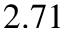Convert formula to latex. <formula><loc_0><loc_0><loc_500><loc_500>2 . 7 1</formula> 